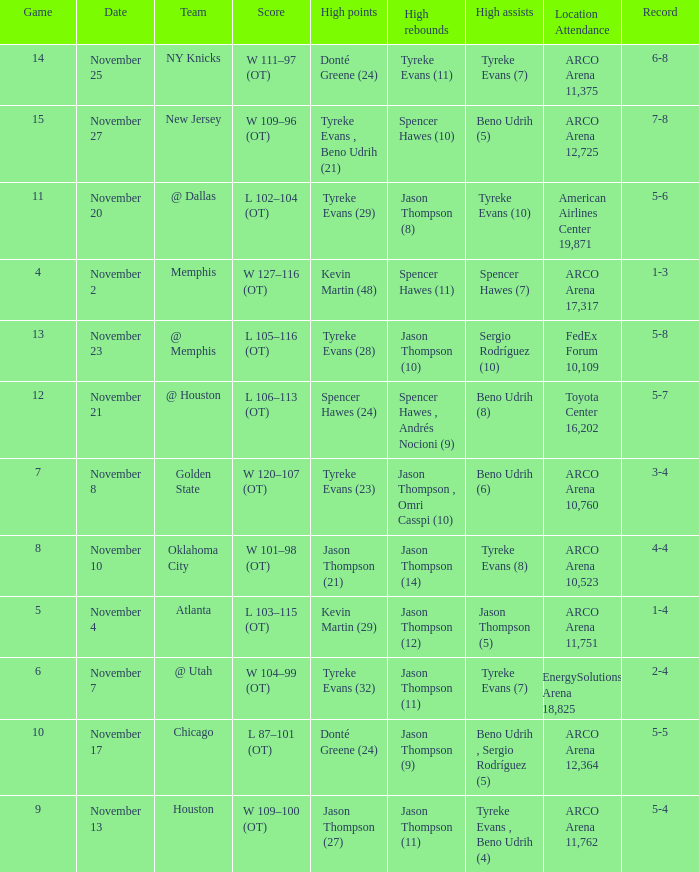If the record is 5-8, what is the team name? @ Memphis. 